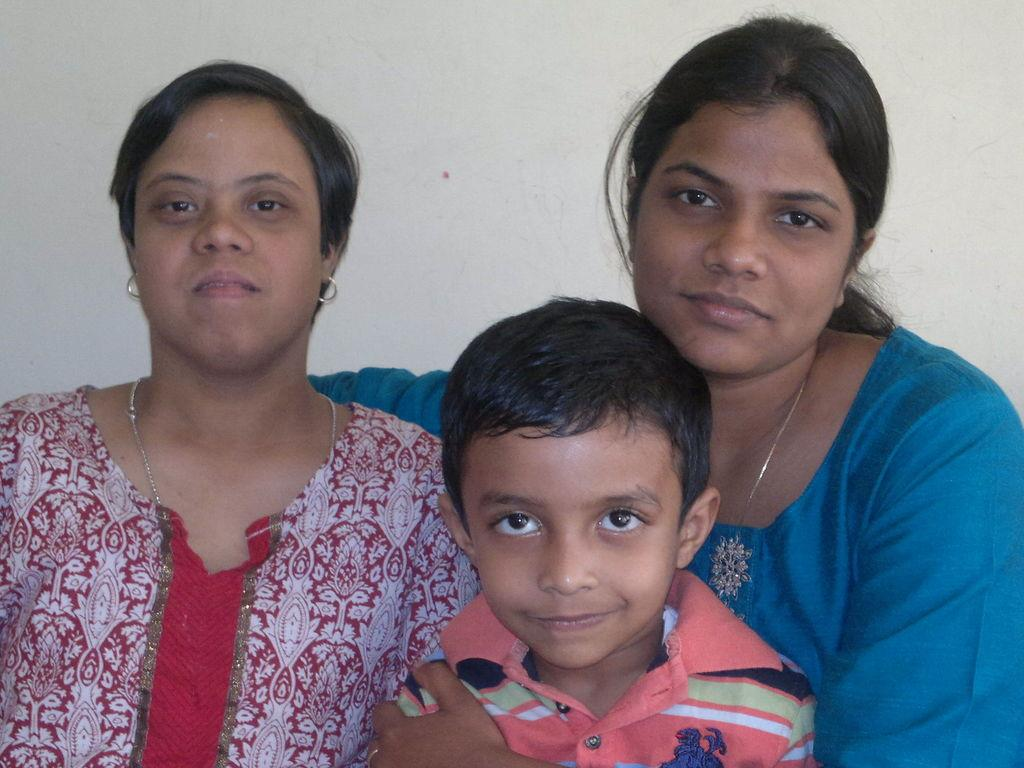How many individuals are present in the image? There are three people in the image. What is located behind the people? There is a wall behind the people. What type of quill can be seen in the hands of the people in the image? There is no quill present in the image; the people are not holding any writing instruments. 